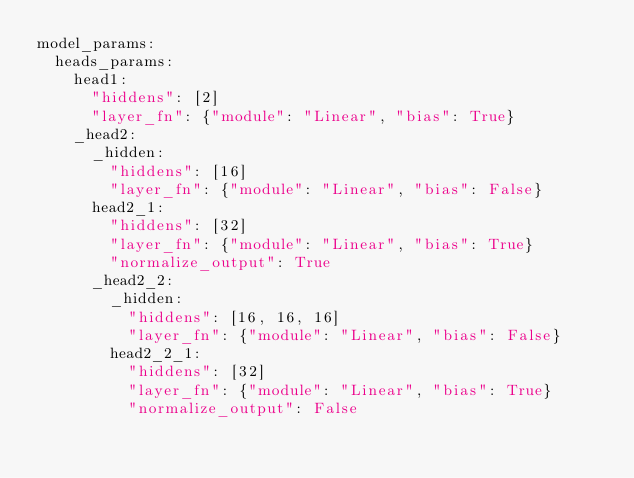Convert code to text. <code><loc_0><loc_0><loc_500><loc_500><_YAML_>model_params:
  heads_params:
    head1:
      "hiddens": [2]
      "layer_fn": {"module": "Linear", "bias": True}
    _head2:
      _hidden:
        "hiddens": [16]
        "layer_fn": {"module": "Linear", "bias": False}
      head2_1:
        "hiddens": [32]
        "layer_fn": {"module": "Linear", "bias": True}
        "normalize_output": True
      _head2_2:
        _hidden:
          "hiddens": [16, 16, 16]
          "layer_fn": {"module": "Linear", "bias": False}
        head2_2_1:
          "hiddens": [32]
          "layer_fn": {"module": "Linear", "bias": True}
          "normalize_output": False</code> 